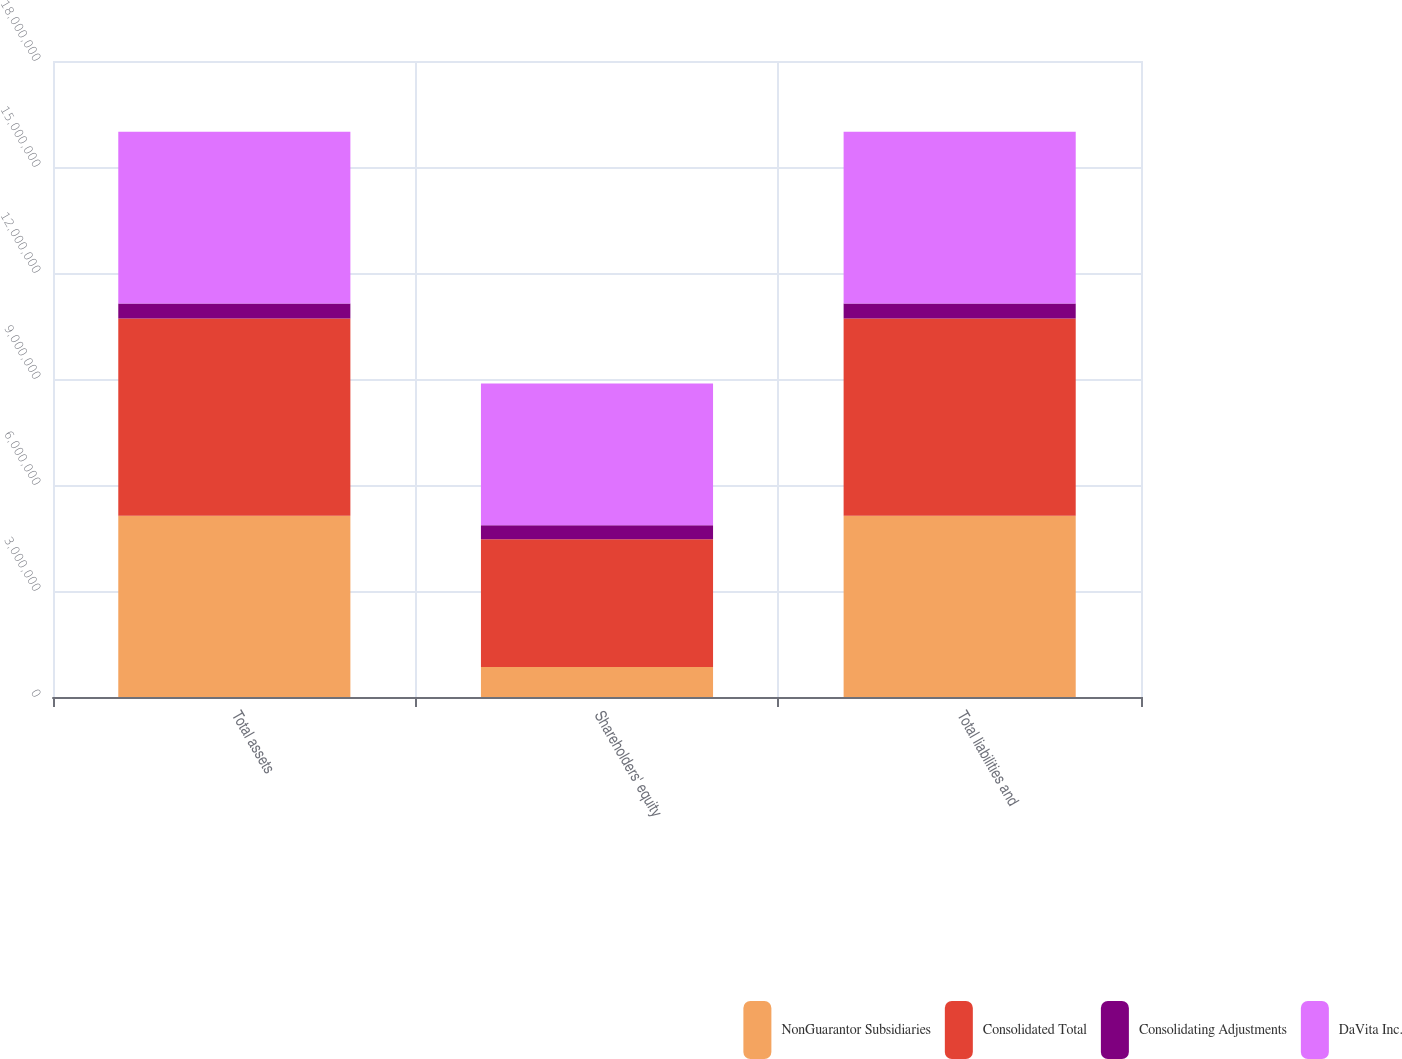Convert chart. <chart><loc_0><loc_0><loc_500><loc_500><stacked_bar_chart><ecel><fcel>Total assets<fcel>Shareholders' equity<fcel>Total liabilities and<nl><fcel>NonGuarantor Subsidiaries<fcel>5.12945e+06<fcel>850609<fcel>5.12945e+06<nl><fcel>Consolidated Total<fcel>5.5816e+06<fcel>3.61668e+06<fcel>5.5816e+06<nl><fcel>Consolidating Adjustments<fcel>428638<fcel>394807<fcel>428638<nl><fcel>DaVita Inc.<fcel>4.85993e+06<fcel>4.01149e+06<fcel>4.85993e+06<nl></chart> 